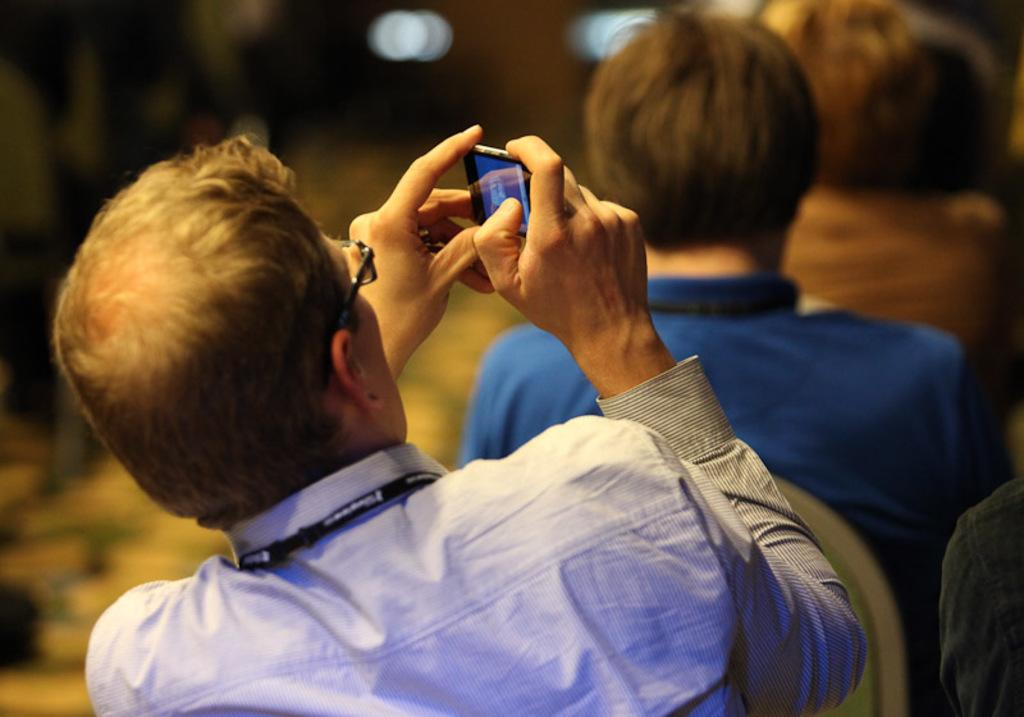Who is the main subject in the image? There is a man in the image. What is the man wearing? The man is wearing a blue shirt. What object is the man holding? The man is holding a cellphone. Can you describe the people sitting behind the man? There are other persons sitting behind the man. What type of thrill can be seen on the man's face in the image? There is no indication of a thrill on the man's face in the image. 